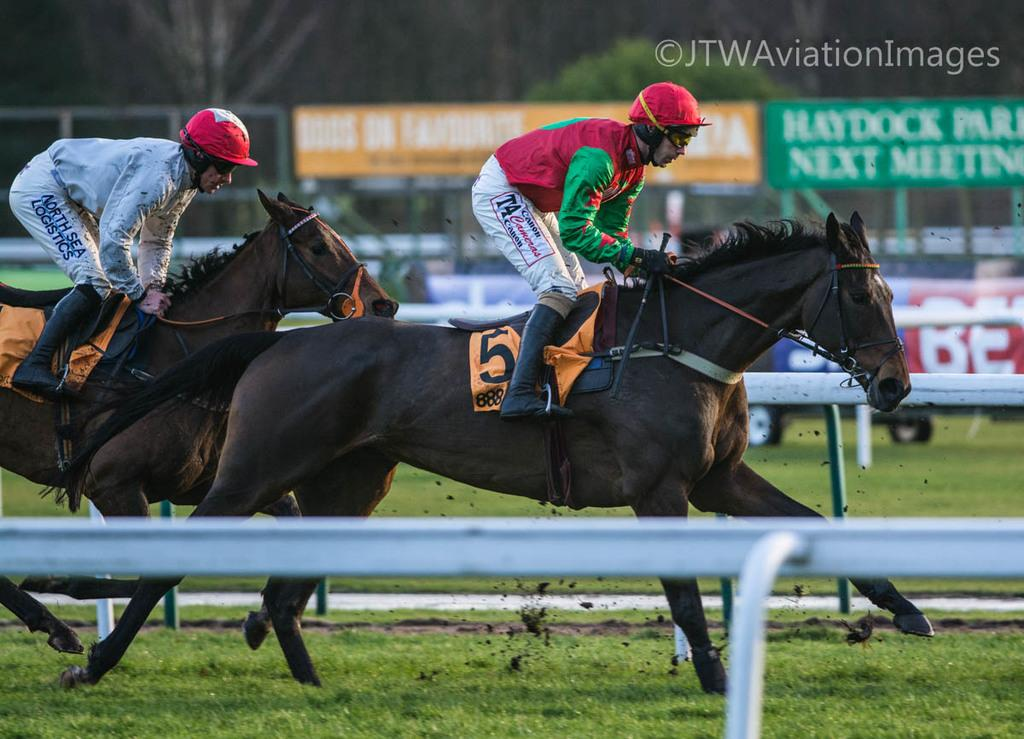What activity are the people in the image engaged in? The people in the image are riding horses. What protective gear are the people wearing while riding horses? The people are wearing helmets. What is located beside the people riding horses? There is a fence beside the people riding horses. What can be seen in the background of the image? There are hoardings and trees visible in the background of the image. What note is the star playing in the image? There is no star or musical instrument present in the image; it features people riding horses. 